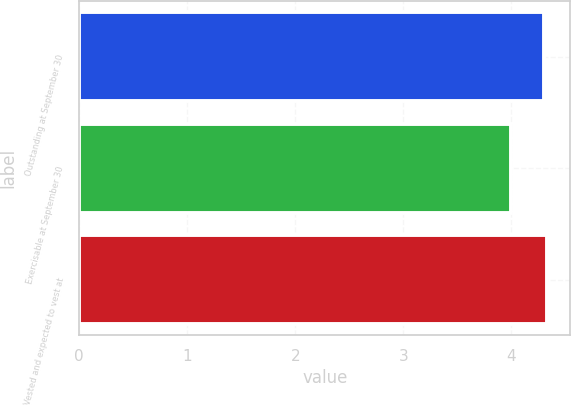Convert chart to OTSL. <chart><loc_0><loc_0><loc_500><loc_500><bar_chart><fcel>Outstanding at September 30<fcel>Exercisable at September 30<fcel>Vested and expected to vest at<nl><fcel>4.3<fcel>4<fcel>4.33<nl></chart> 